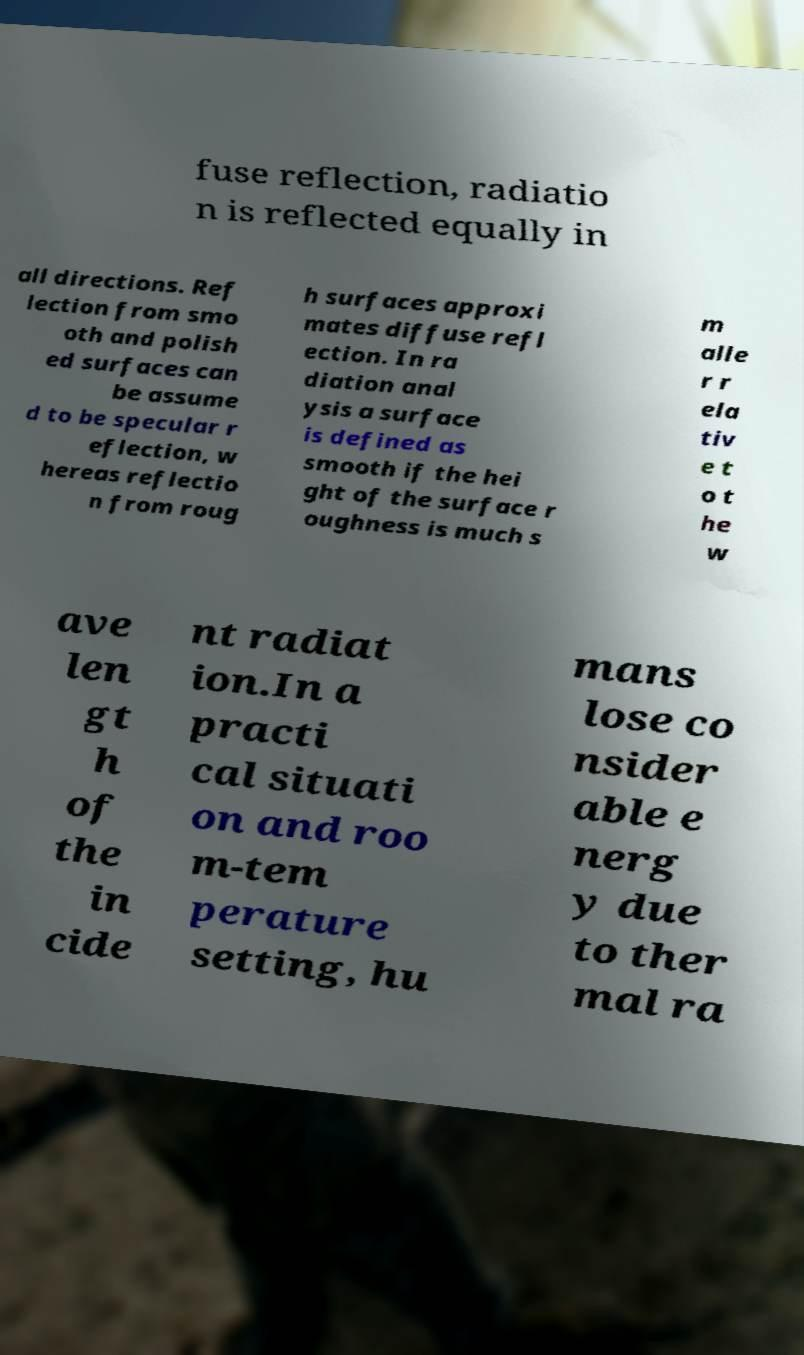For documentation purposes, I need the text within this image transcribed. Could you provide that? fuse reflection, radiatio n is reflected equally in all directions. Ref lection from smo oth and polish ed surfaces can be assume d to be specular r eflection, w hereas reflectio n from roug h surfaces approxi mates diffuse refl ection. In ra diation anal ysis a surface is defined as smooth if the hei ght of the surface r oughness is much s m alle r r ela tiv e t o t he w ave len gt h of the in cide nt radiat ion.In a practi cal situati on and roo m-tem perature setting, hu mans lose co nsider able e nerg y due to ther mal ra 